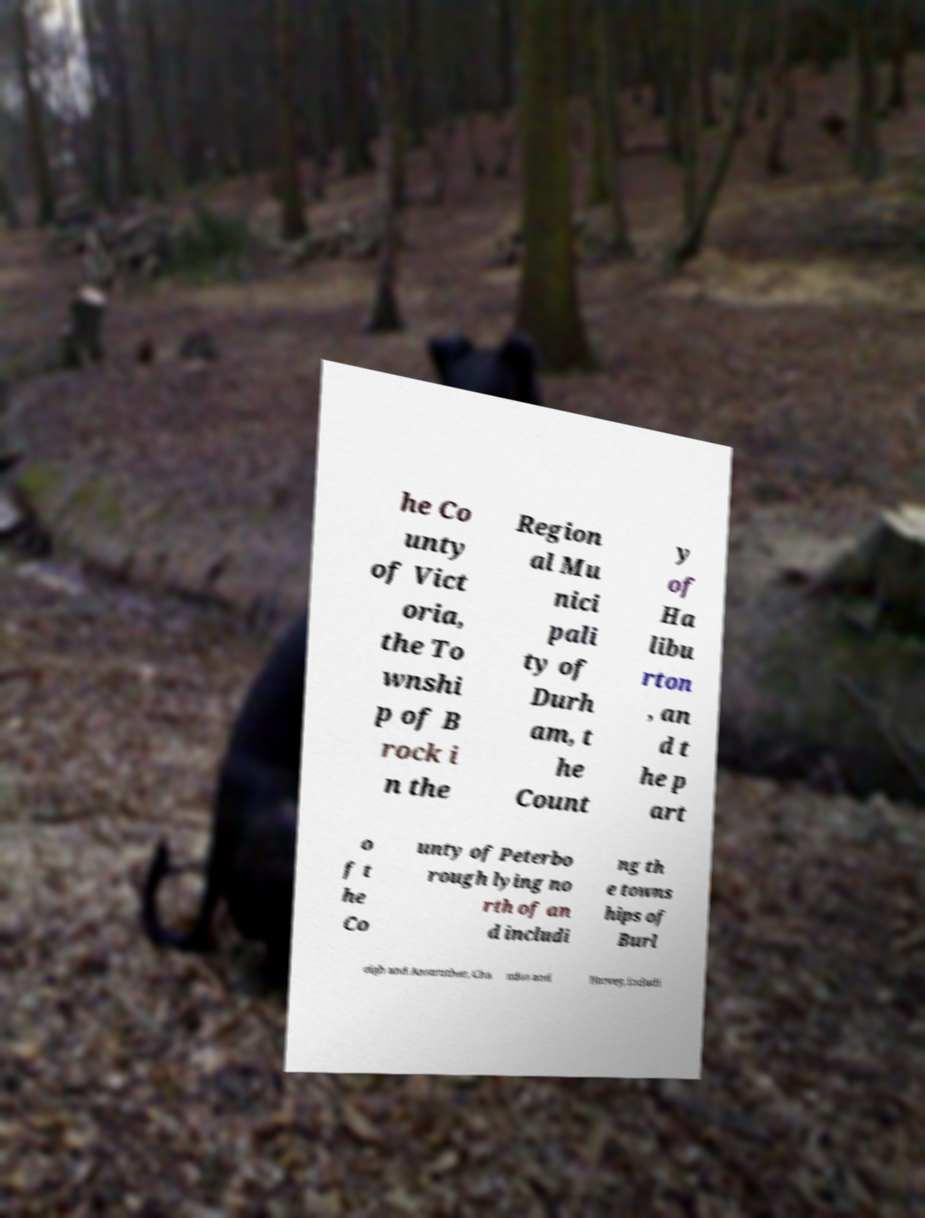What messages or text are displayed in this image? I need them in a readable, typed format. he Co unty of Vict oria, the To wnshi p of B rock i n the Region al Mu nici pali ty of Durh am, t he Count y of Ha libu rton , an d t he p art o f t he Co unty of Peterbo rough lying no rth of an d includi ng th e towns hips of Burl eigh and Anstruther, Cha ndos and Harvey, includi 